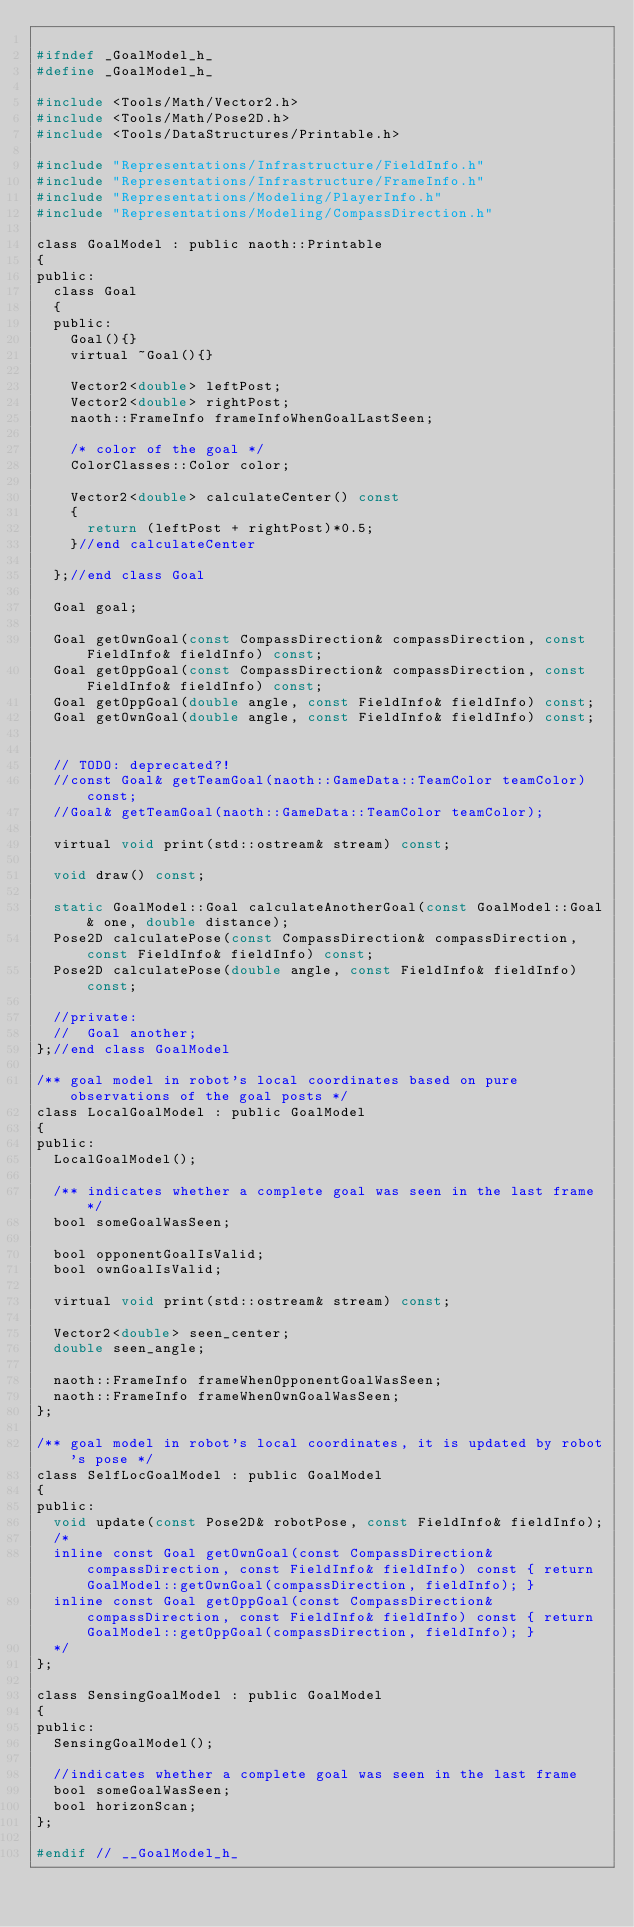Convert code to text. <code><loc_0><loc_0><loc_500><loc_500><_C_>
#ifndef _GoalModel_h_
#define _GoalModel_h_

#include <Tools/Math/Vector2.h>
#include <Tools/Math/Pose2D.h>
#include <Tools/DataStructures/Printable.h>

#include "Representations/Infrastructure/FieldInfo.h"
#include "Representations/Infrastructure/FrameInfo.h"
#include "Representations/Modeling/PlayerInfo.h"
#include "Representations/Modeling/CompassDirection.h"

class GoalModel : public naoth::Printable
{
public:
  class Goal
  {
  public:
    Goal(){}
    virtual ~Goal(){}

    Vector2<double> leftPost;
    Vector2<double> rightPost;
    naoth::FrameInfo frameInfoWhenGoalLastSeen;
    
    /* color of the goal */
    ColorClasses::Color color;

    Vector2<double> calculateCenter() const
    {
      return (leftPost + rightPost)*0.5;
    }//end calculateCenter

  };//end class Goal

  Goal goal;

  Goal getOwnGoal(const CompassDirection& compassDirection, const FieldInfo& fieldInfo) const;
  Goal getOppGoal(const CompassDirection& compassDirection, const FieldInfo& fieldInfo) const;
  Goal getOppGoal(double angle, const FieldInfo& fieldInfo) const;
  Goal getOwnGoal(double angle, const FieldInfo& fieldInfo) const;


  // TODO: deprecated?!
  //const Goal& getTeamGoal(naoth::GameData::TeamColor teamColor) const;
  //Goal& getTeamGoal(naoth::GameData::TeamColor teamColor);

  virtual void print(std::ostream& stream) const;

  void draw() const;

  static GoalModel::Goal calculateAnotherGoal(const GoalModel::Goal& one, double distance);
  Pose2D calculatePose(const CompassDirection& compassDirection, const FieldInfo& fieldInfo) const;
  Pose2D calculatePose(double angle, const FieldInfo& fieldInfo) const;

  //private:
  //  Goal another;
};//end class GoalModel

/** goal model in robot's local coordinates based on pure observations of the goal posts */
class LocalGoalModel : public GoalModel
{
public:
  LocalGoalModel();

  /** indicates whether a complete goal was seen in the last frame */
  bool someGoalWasSeen;

  bool opponentGoalIsValid;
  bool ownGoalIsValid;

  virtual void print(std::ostream& stream) const;

  Vector2<double> seen_center;
  double seen_angle;

  naoth::FrameInfo frameWhenOpponentGoalWasSeen;
  naoth::FrameInfo frameWhenOwnGoalWasSeen;
};

/** goal model in robot's local coordinates, it is updated by robot's pose */
class SelfLocGoalModel : public GoalModel
{
public:
  void update(const Pose2D& robotPose, const FieldInfo& fieldInfo);
  /*
  inline const Goal getOwnGoal(const CompassDirection& compassDirection, const FieldInfo& fieldInfo) const { return GoalModel::getOwnGoal(compassDirection, fieldInfo); }
  inline const Goal getOppGoal(const CompassDirection& compassDirection, const FieldInfo& fieldInfo) const { return GoalModel::getOppGoal(compassDirection, fieldInfo); }
  */
};

class SensingGoalModel : public GoalModel
{
public:
  SensingGoalModel();

  //indicates whether a complete goal was seen in the last frame
  bool someGoalWasSeen;
  bool horizonScan;
};

#endif // __GoalModel_h_
</code> 